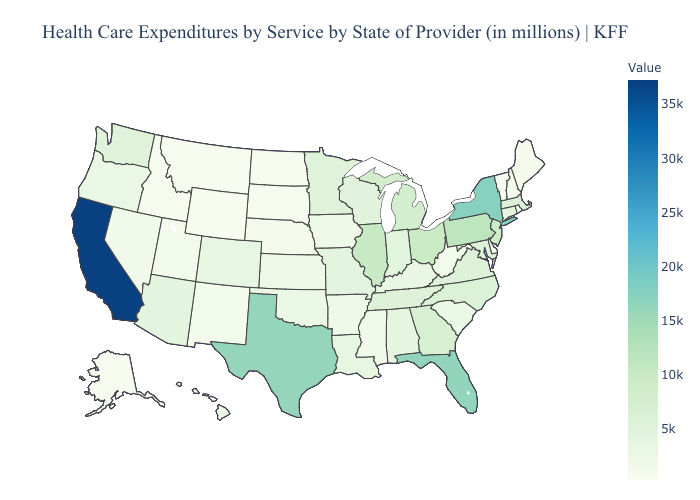Does North Carolina have the lowest value in the South?
Give a very brief answer. No. Does Illinois have a lower value than South Dakota?
Quick response, please. No. Which states have the lowest value in the MidWest?
Short answer required. South Dakota. Among the states that border Massachusetts , which have the highest value?
Concise answer only. New York. Among the states that border Arkansas , does Texas have the highest value?
Keep it brief. Yes. Does California have the highest value in the West?
Keep it brief. Yes. Does Wyoming have the lowest value in the USA?
Quick response, please. Yes. 